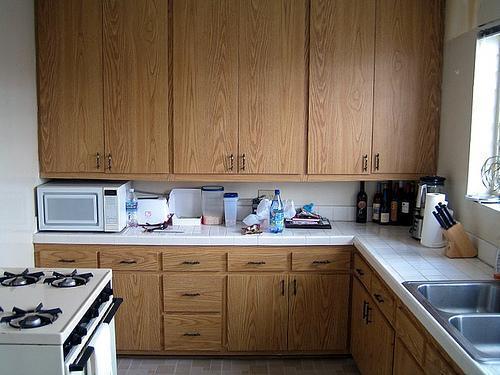How many cabinets doors are on top?
Give a very brief answer. 6. How many motorcycles are parked off the street?
Give a very brief answer. 0. 